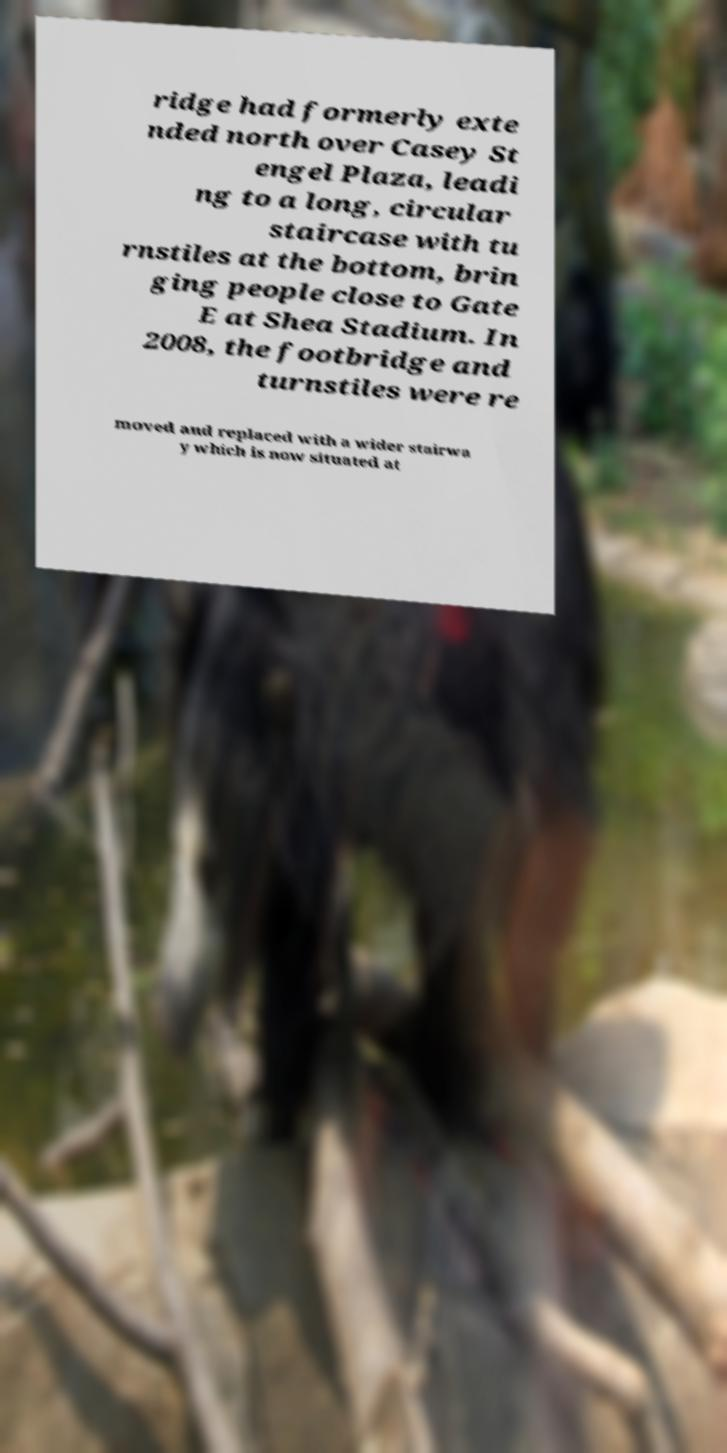Can you accurately transcribe the text from the provided image for me? ridge had formerly exte nded north over Casey St engel Plaza, leadi ng to a long, circular staircase with tu rnstiles at the bottom, brin ging people close to Gate E at Shea Stadium. In 2008, the footbridge and turnstiles were re moved and replaced with a wider stairwa y which is now situated at 